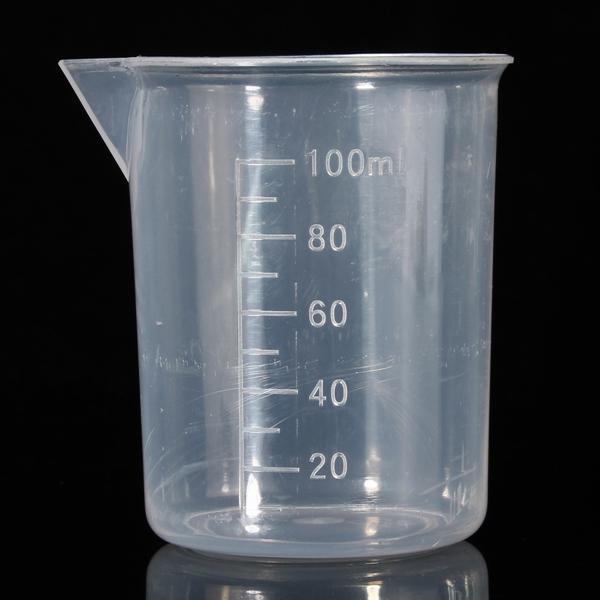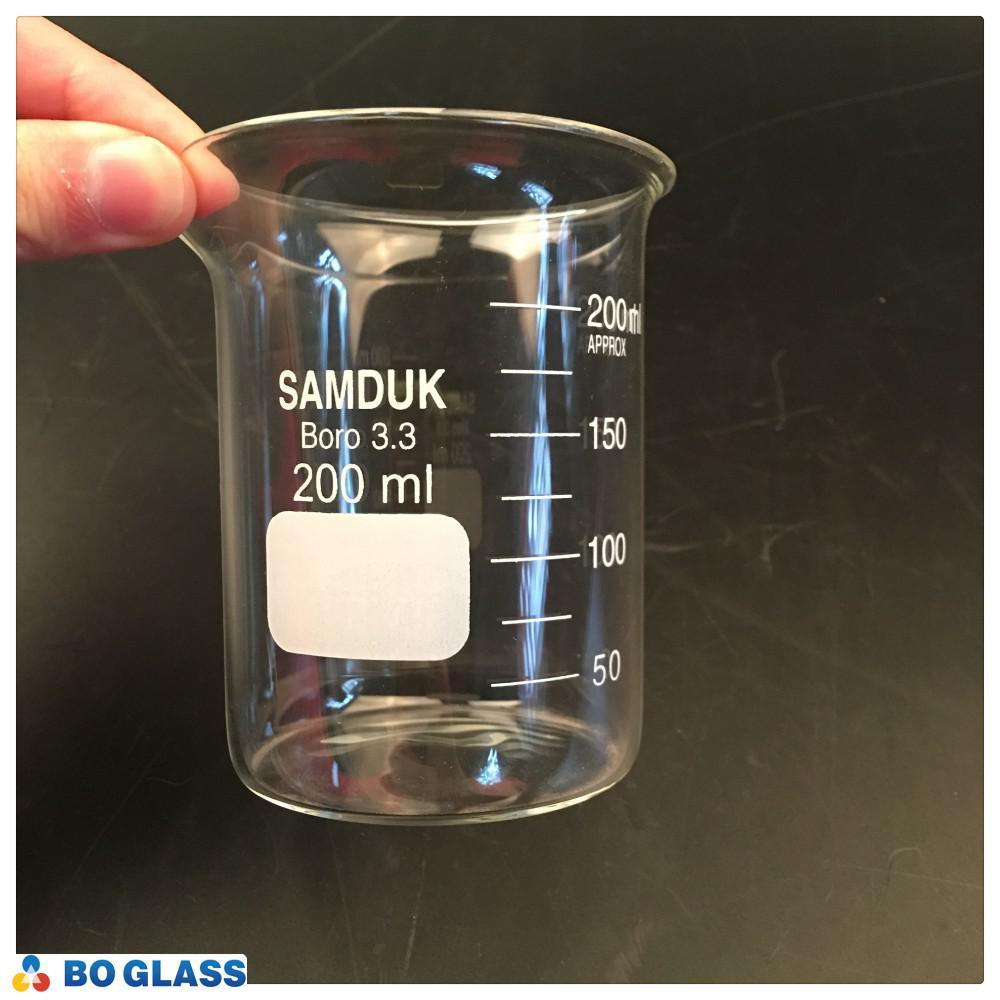The first image is the image on the left, the second image is the image on the right. Analyze the images presented: Is the assertion "The right image includes at least one cylindrical beaker made of clear glass, and the left image includes multiple glass beakers with wide bases that taper to a narrower top." valid? Answer yes or no. No. The first image is the image on the left, the second image is the image on the right. For the images shown, is this caption "All of the containers are the same basic shape." true? Answer yes or no. Yes. 